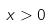<formula> <loc_0><loc_0><loc_500><loc_500>x > 0</formula> 